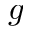<formula> <loc_0><loc_0><loc_500><loc_500>g</formula> 